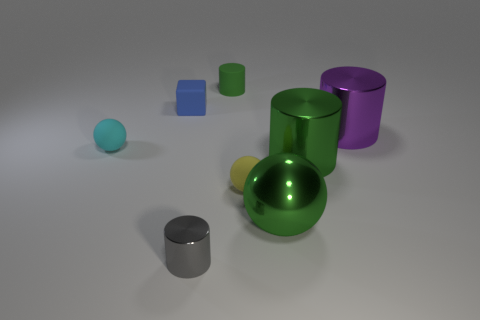Subtract all green cylinders. How many were subtracted if there are1green cylinders left? 1 Subtract all gray cylinders. How many cylinders are left? 3 Add 1 matte cylinders. How many objects exist? 9 Subtract all brown spheres. Subtract all yellow cylinders. How many spheres are left? 3 Subtract all brown blocks. How many brown balls are left? 0 Subtract all big purple metal objects. Subtract all large purple matte balls. How many objects are left? 7 Add 5 tiny matte spheres. How many tiny matte spheres are left? 7 Add 1 small green balls. How many small green balls exist? 1 Subtract all purple cylinders. How many cylinders are left? 3 Subtract 0 cyan cylinders. How many objects are left? 8 